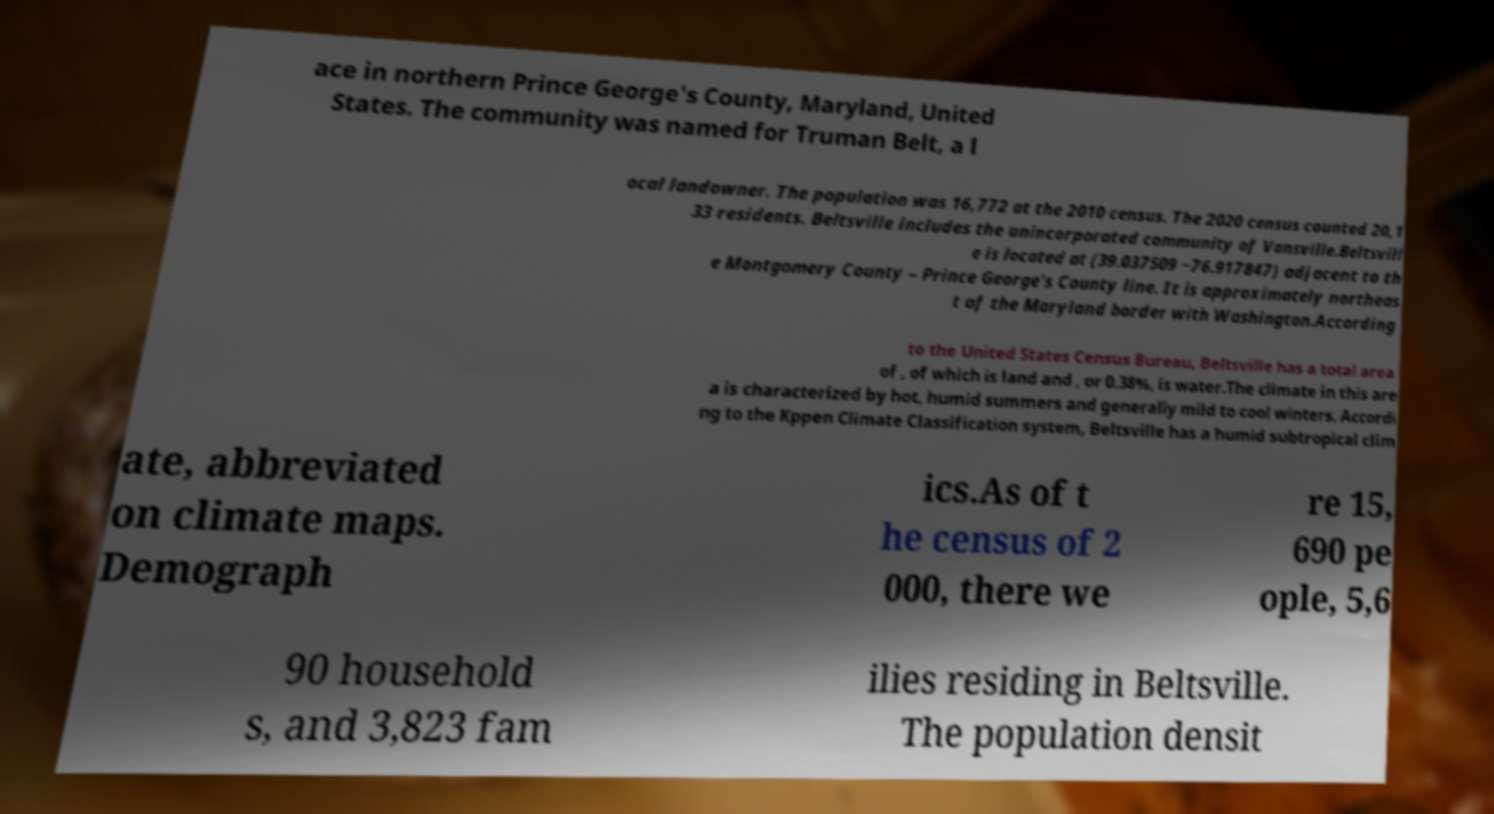Could you assist in decoding the text presented in this image and type it out clearly? ace in northern Prince George's County, Maryland, United States. The community was named for Truman Belt, a l ocal landowner. The population was 16,772 at the 2010 census. The 2020 census counted 20,1 33 residents. Beltsville includes the unincorporated community of Vansville.Beltsvill e is located at (39.037509 −76.917847) adjacent to th e Montgomery County – Prince George's County line. It is approximately northeas t of the Maryland border with Washington.According to the United States Census Bureau, Beltsville has a total area of , of which is land and , or 0.38%, is water.The climate in this are a is characterized by hot, humid summers and generally mild to cool winters. Accordi ng to the Kppen Climate Classification system, Beltsville has a humid subtropical clim ate, abbreviated on climate maps. Demograph ics.As of t he census of 2 000, there we re 15, 690 pe ople, 5,6 90 household s, and 3,823 fam ilies residing in Beltsville. The population densit 